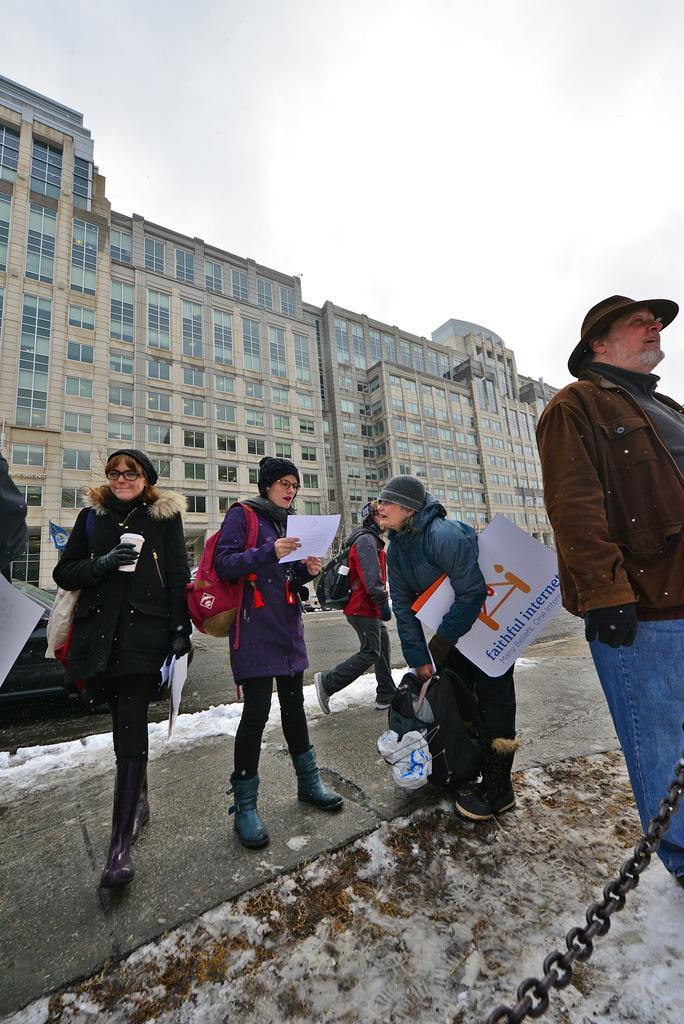Describe this image in one or two sentences. In this image we can see a group of people on the ground. In that some are holding a board with some text on it, a paper and a glass. On the backside we can see a building and the sky. In the foreground we can see a chain. 